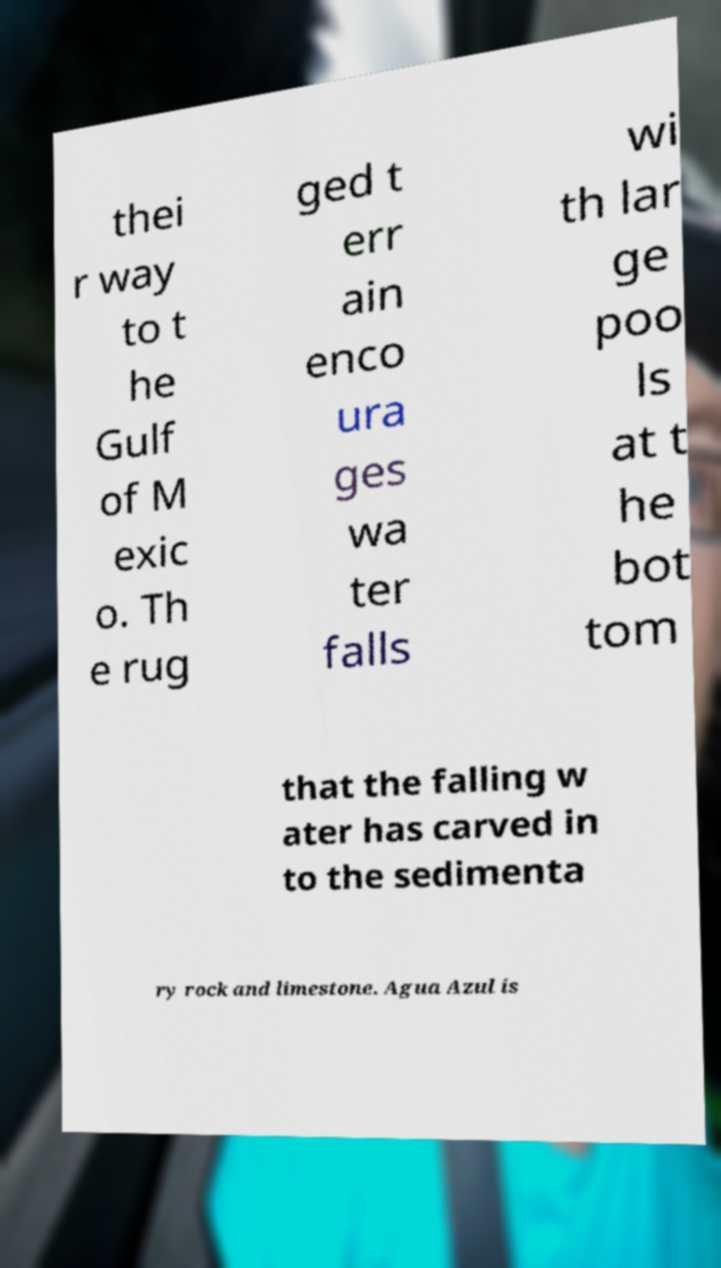There's text embedded in this image that I need extracted. Can you transcribe it verbatim? thei r way to t he Gulf of M exic o. Th e rug ged t err ain enco ura ges wa ter falls wi th lar ge poo ls at t he bot tom that the falling w ater has carved in to the sedimenta ry rock and limestone. Agua Azul is 